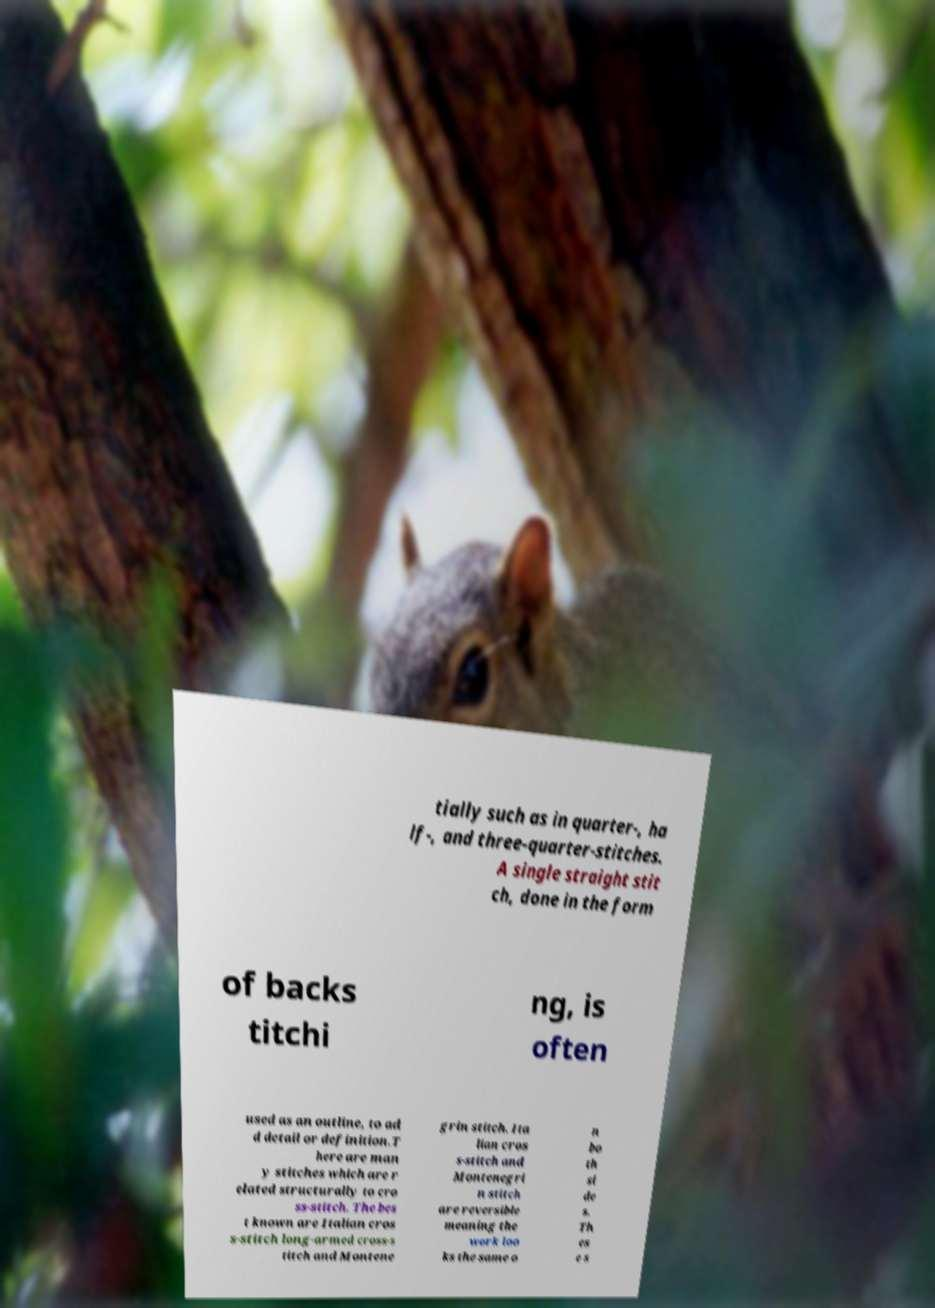Could you assist in decoding the text presented in this image and type it out clearly? tially such as in quarter-, ha lf-, and three-quarter-stitches. A single straight stit ch, done in the form of backs titchi ng, is often used as an outline, to ad d detail or definition.T here are man y stitches which are r elated structurally to cro ss-stitch. The bes t known are Italian cros s-stitch long-armed cross-s titch and Montene grin stitch. Ita lian cros s-stitch and Montenegri n stitch are reversible meaning the work loo ks the same o n bo th si de s. Th es e s 